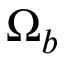<formula> <loc_0><loc_0><loc_500><loc_500>\Omega _ { b }</formula> 